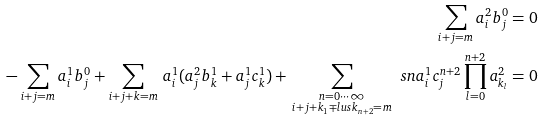Convert formula to latex. <formula><loc_0><loc_0><loc_500><loc_500>\sum _ { i + j = m } a ^ { 2 } _ { i } b ^ { 0 } _ { j } = 0 \\ - \sum _ { i + j = m } a ^ { 1 } _ { i } b ^ { 0 } _ { j } + \sum _ { i + j + k = m } \, a ^ { 1 } _ { i } ( a ^ { 2 } _ { j } b ^ { 1 } _ { k } + a ^ { 1 } _ { j } c ^ { 1 } _ { k } ) + \, \sum _ { \substack { n = 0 \cdots \infty \\ i + j + k _ { 1 } \mp l u s k _ { n + 2 } = m } } \, \ s n a _ { i } ^ { 1 } c _ { j } ^ { n + 2 } \prod _ { l = 0 } ^ { n + 2 } a ^ { 2 } _ { k _ { l } } = 0</formula> 